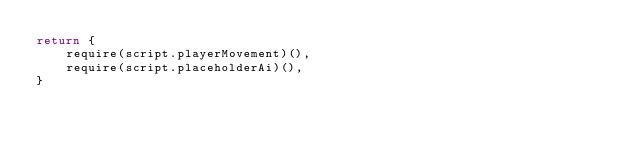Convert code to text. <code><loc_0><loc_0><loc_500><loc_500><_Lua_>return {
	require(script.playerMovement)(),
	require(script.placeholderAi)(),
}</code> 